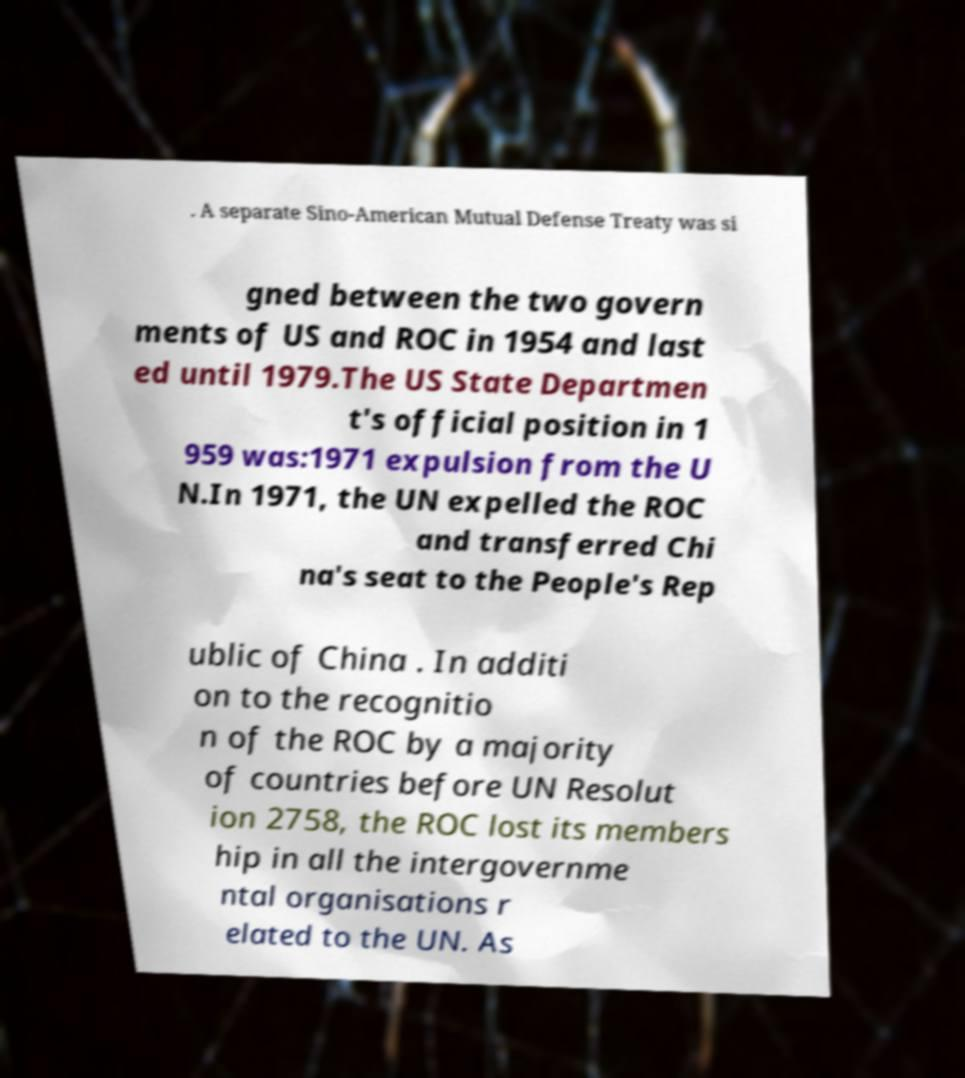I need the written content from this picture converted into text. Can you do that? . A separate Sino-American Mutual Defense Treaty was si gned between the two govern ments of US and ROC in 1954 and last ed until 1979.The US State Departmen t's official position in 1 959 was:1971 expulsion from the U N.In 1971, the UN expelled the ROC and transferred Chi na's seat to the People's Rep ublic of China . In additi on to the recognitio n of the ROC by a majority of countries before UN Resolut ion 2758, the ROC lost its members hip in all the intergovernme ntal organisations r elated to the UN. As 